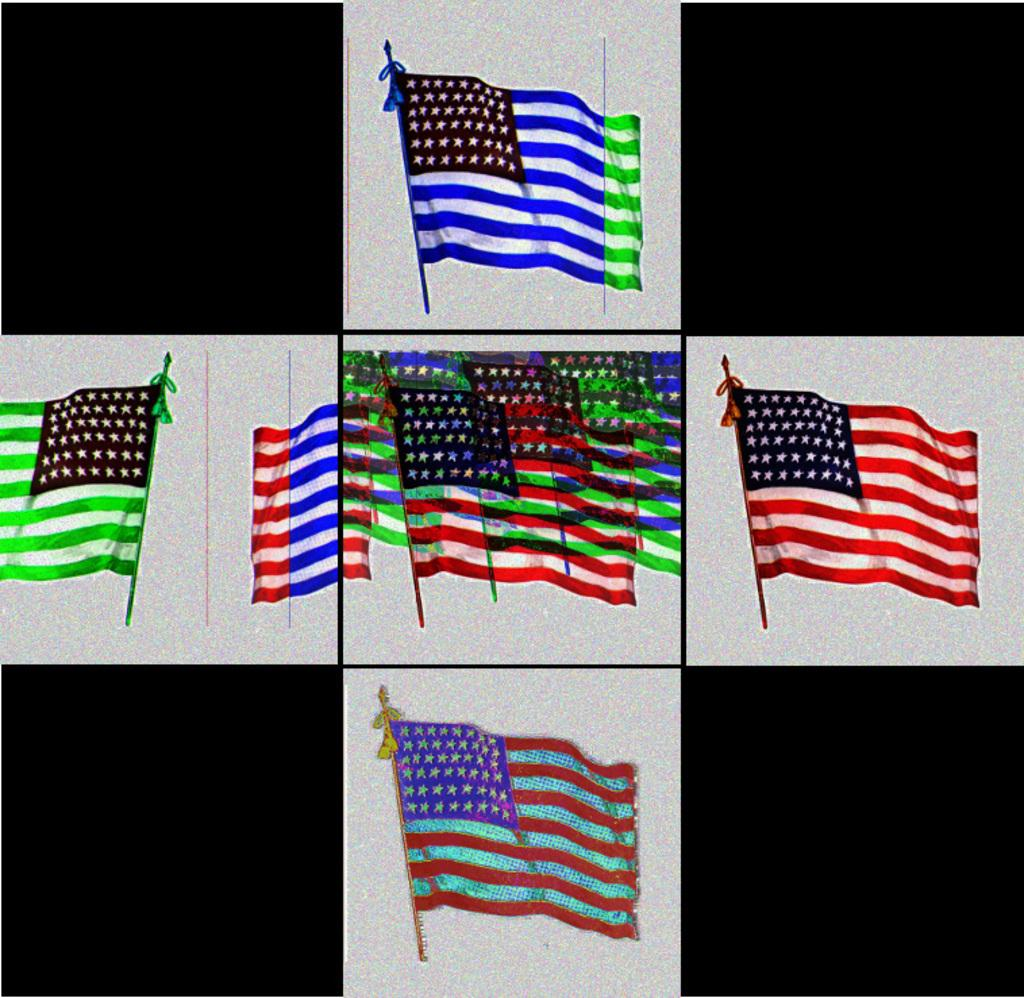What objects are present in the image that represent a country or symbol? There are flags in the image. What colors can be seen on the flags in the image? The flags have red, white, and blue colors. Where is the seashore located in the image? There is no seashore present in the image; it only features flags with red, white, and blue colors. What type of food is being served in the lunchroom in the image? There is no lunchroom present in the image; it only features flags with red, white, and blue colors. 